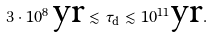<formula> <loc_0><loc_0><loc_500><loc_500>3 \cdot 1 0 ^ { 8 } \, \text {yr} \lesssim \tau _ { \text {d} } \lesssim 1 0 ^ { 1 1 } \text {yr} .</formula> 